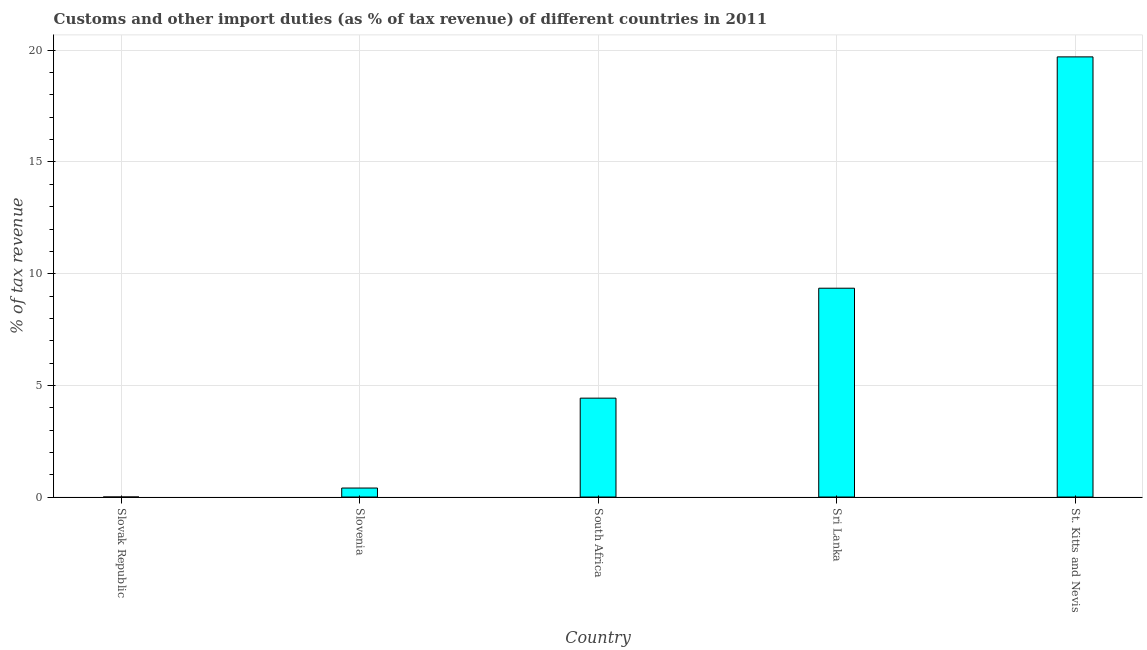Does the graph contain any zero values?
Your answer should be very brief. No. Does the graph contain grids?
Give a very brief answer. Yes. What is the title of the graph?
Your response must be concise. Customs and other import duties (as % of tax revenue) of different countries in 2011. What is the label or title of the Y-axis?
Provide a succinct answer. % of tax revenue. What is the customs and other import duties in Slovak Republic?
Offer a terse response. 0. Across all countries, what is the maximum customs and other import duties?
Make the answer very short. 19.71. Across all countries, what is the minimum customs and other import duties?
Your answer should be very brief. 0. In which country was the customs and other import duties maximum?
Offer a very short reply. St. Kitts and Nevis. In which country was the customs and other import duties minimum?
Offer a terse response. Slovak Republic. What is the sum of the customs and other import duties?
Offer a terse response. 33.89. What is the difference between the customs and other import duties in Slovak Republic and Slovenia?
Provide a short and direct response. -0.4. What is the average customs and other import duties per country?
Your answer should be very brief. 6.78. What is the median customs and other import duties?
Your answer should be compact. 4.43. In how many countries, is the customs and other import duties greater than 17 %?
Give a very brief answer. 1. What is the ratio of the customs and other import duties in South Africa to that in Sri Lanka?
Provide a succinct answer. 0.47. Is the difference between the customs and other import duties in Slovak Republic and South Africa greater than the difference between any two countries?
Offer a terse response. No. What is the difference between the highest and the second highest customs and other import duties?
Your answer should be compact. 10.36. Is the sum of the customs and other import duties in Slovak Republic and Slovenia greater than the maximum customs and other import duties across all countries?
Provide a short and direct response. No. What is the difference between the highest and the lowest customs and other import duties?
Make the answer very short. 19.71. In how many countries, is the customs and other import duties greater than the average customs and other import duties taken over all countries?
Provide a succinct answer. 2. What is the difference between two consecutive major ticks on the Y-axis?
Provide a succinct answer. 5. What is the % of tax revenue in Slovak Republic?
Give a very brief answer. 0. What is the % of tax revenue of Slovenia?
Keep it short and to the point. 0.4. What is the % of tax revenue of South Africa?
Your response must be concise. 4.43. What is the % of tax revenue of Sri Lanka?
Offer a very short reply. 9.35. What is the % of tax revenue in St. Kitts and Nevis?
Give a very brief answer. 19.71. What is the difference between the % of tax revenue in Slovak Republic and Slovenia?
Keep it short and to the point. -0.4. What is the difference between the % of tax revenue in Slovak Republic and South Africa?
Your answer should be very brief. -4.43. What is the difference between the % of tax revenue in Slovak Republic and Sri Lanka?
Make the answer very short. -9.35. What is the difference between the % of tax revenue in Slovak Republic and St. Kitts and Nevis?
Ensure brevity in your answer.  -19.71. What is the difference between the % of tax revenue in Slovenia and South Africa?
Ensure brevity in your answer.  -4.02. What is the difference between the % of tax revenue in Slovenia and Sri Lanka?
Provide a succinct answer. -8.95. What is the difference between the % of tax revenue in Slovenia and St. Kitts and Nevis?
Provide a succinct answer. -19.3. What is the difference between the % of tax revenue in South Africa and Sri Lanka?
Your answer should be very brief. -4.92. What is the difference between the % of tax revenue in South Africa and St. Kitts and Nevis?
Provide a short and direct response. -15.28. What is the difference between the % of tax revenue in Sri Lanka and St. Kitts and Nevis?
Your response must be concise. -10.36. What is the ratio of the % of tax revenue in Slovak Republic to that in Slovenia?
Offer a very short reply. 0. What is the ratio of the % of tax revenue in Slovak Republic to that in South Africa?
Give a very brief answer. 0. What is the ratio of the % of tax revenue in Slovak Republic to that in Sri Lanka?
Keep it short and to the point. 0. What is the ratio of the % of tax revenue in Slovak Republic to that in St. Kitts and Nevis?
Give a very brief answer. 0. What is the ratio of the % of tax revenue in Slovenia to that in South Africa?
Provide a succinct answer. 0.09. What is the ratio of the % of tax revenue in Slovenia to that in Sri Lanka?
Keep it short and to the point. 0.04. What is the ratio of the % of tax revenue in South Africa to that in Sri Lanka?
Offer a terse response. 0.47. What is the ratio of the % of tax revenue in South Africa to that in St. Kitts and Nevis?
Offer a very short reply. 0.23. What is the ratio of the % of tax revenue in Sri Lanka to that in St. Kitts and Nevis?
Make the answer very short. 0.47. 